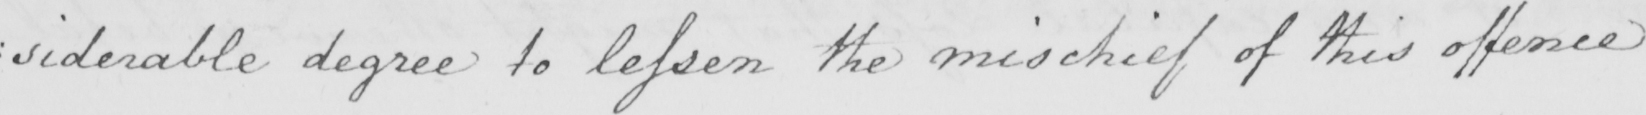Can you tell me what this handwritten text says? : siderable degree to lessen the mischief of this offence 